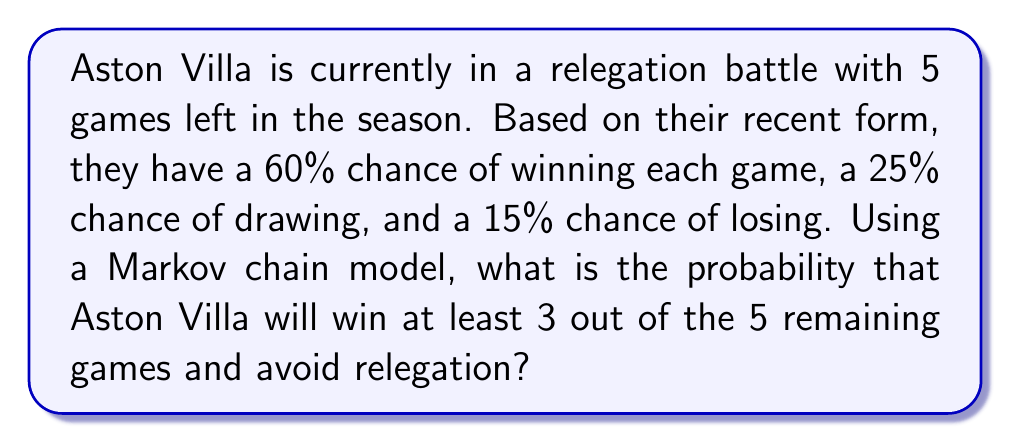Solve this math problem. Let's approach this step-by-step using a Markov chain model:

1) First, we need to define our states. Let's use the number of wins as our state:
   State 0: 0 wins, State 1: 1 win, State 2: 2 wins, State 3: 3 wins, State 4: 4 wins, State 5: 5 wins

2) Now, let's create our transition matrix P:

   $$P = \begin{bmatrix}
   0.15 & 0.60 & 0.25 & 0 & 0 & 0 \\
   0 & 0.15 & 0.60 & 0.25 & 0 & 0 \\
   0 & 0 & 0.15 & 0.60 & 0.25 & 0 \\
   0 & 0 & 0 & 0.15 & 0.60 & 0.25 \\
   0 & 0 & 0 & 0 & 0.15 & 0.85 \\
   0 & 0 & 0 & 0 & 0 & 1
   \end{bmatrix}$$

3) We start in State 0 with initial probability vector:
   $$\pi_0 = \begin{bmatrix} 1 & 0 & 0 & 0 & 0 & 0 \end{bmatrix}$$

4) To find the probability distribution after 5 games, we calculate:
   $$\pi_5 = \pi_0 P^5$$

5) Using matrix multiplication (which can be done with a calculator or computer), we get:
   $$\pi_5 \approx \begin{bmatrix} 0.0008 & 0.0160 & 0.1201 & 0.3602 & 0.3602 & 0.1427 \end{bmatrix}$$

6) The probability of winning at least 3 games is the sum of the probabilities for states 3, 4, and 5:
   $$P(\text{at least 3 wins}) = 0.3602 + 0.3602 + 0.1427 = 0.8631$$

Therefore, the probability that Aston Villa will win at least 3 out of the 5 remaining games and avoid relegation is approximately 0.8631 or 86.31%.
Answer: 0.8631 